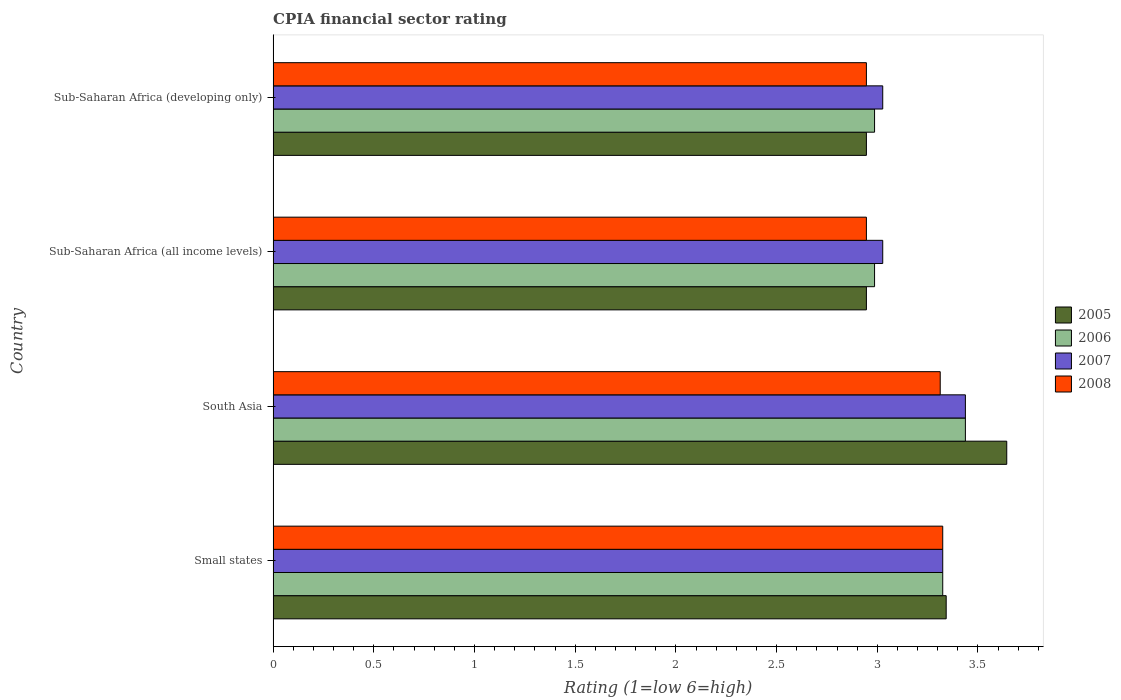How many different coloured bars are there?
Your answer should be compact. 4. How many groups of bars are there?
Give a very brief answer. 4. What is the CPIA rating in 2005 in South Asia?
Ensure brevity in your answer.  3.64. Across all countries, what is the maximum CPIA rating in 2005?
Provide a short and direct response. 3.64. Across all countries, what is the minimum CPIA rating in 2008?
Your answer should be compact. 2.95. In which country was the CPIA rating in 2006 minimum?
Provide a succinct answer. Sub-Saharan Africa (all income levels). What is the total CPIA rating in 2007 in the graph?
Your response must be concise. 12.82. What is the difference between the CPIA rating in 2007 in Small states and that in South Asia?
Your answer should be compact. -0.11. What is the difference between the CPIA rating in 2008 in South Asia and the CPIA rating in 2007 in Sub-Saharan Africa (all income levels)?
Give a very brief answer. 0.29. What is the average CPIA rating in 2008 per country?
Provide a short and direct response. 3.13. What is the difference between the CPIA rating in 2005 and CPIA rating in 2006 in South Asia?
Your response must be concise. 0.21. What is the ratio of the CPIA rating in 2007 in Sub-Saharan Africa (all income levels) to that in Sub-Saharan Africa (developing only)?
Offer a terse response. 1. What is the difference between the highest and the second highest CPIA rating in 2008?
Keep it short and to the point. 0.01. What is the difference between the highest and the lowest CPIA rating in 2005?
Provide a succinct answer. 0.7. In how many countries, is the CPIA rating in 2008 greater than the average CPIA rating in 2008 taken over all countries?
Offer a very short reply. 2. Is it the case that in every country, the sum of the CPIA rating in 2006 and CPIA rating in 2007 is greater than the sum of CPIA rating in 2008 and CPIA rating in 2005?
Your answer should be very brief. No. What does the 3rd bar from the bottom in South Asia represents?
Your answer should be very brief. 2007. How many bars are there?
Your answer should be compact. 16. How are the legend labels stacked?
Your answer should be very brief. Vertical. What is the title of the graph?
Offer a very short reply. CPIA financial sector rating. What is the label or title of the Y-axis?
Give a very brief answer. Country. What is the Rating (1=low 6=high) of 2005 in Small states?
Your response must be concise. 3.34. What is the Rating (1=low 6=high) of 2006 in Small states?
Your answer should be compact. 3.33. What is the Rating (1=low 6=high) of 2007 in Small states?
Keep it short and to the point. 3.33. What is the Rating (1=low 6=high) in 2008 in Small states?
Give a very brief answer. 3.33. What is the Rating (1=low 6=high) of 2005 in South Asia?
Give a very brief answer. 3.64. What is the Rating (1=low 6=high) of 2006 in South Asia?
Keep it short and to the point. 3.44. What is the Rating (1=low 6=high) in 2007 in South Asia?
Make the answer very short. 3.44. What is the Rating (1=low 6=high) of 2008 in South Asia?
Offer a very short reply. 3.31. What is the Rating (1=low 6=high) in 2005 in Sub-Saharan Africa (all income levels)?
Provide a succinct answer. 2.95. What is the Rating (1=low 6=high) of 2006 in Sub-Saharan Africa (all income levels)?
Give a very brief answer. 2.99. What is the Rating (1=low 6=high) of 2007 in Sub-Saharan Africa (all income levels)?
Offer a terse response. 3.03. What is the Rating (1=low 6=high) of 2008 in Sub-Saharan Africa (all income levels)?
Provide a succinct answer. 2.95. What is the Rating (1=low 6=high) in 2005 in Sub-Saharan Africa (developing only)?
Make the answer very short. 2.95. What is the Rating (1=low 6=high) in 2006 in Sub-Saharan Africa (developing only)?
Offer a very short reply. 2.99. What is the Rating (1=low 6=high) in 2007 in Sub-Saharan Africa (developing only)?
Keep it short and to the point. 3.03. What is the Rating (1=low 6=high) in 2008 in Sub-Saharan Africa (developing only)?
Your answer should be very brief. 2.95. Across all countries, what is the maximum Rating (1=low 6=high) of 2005?
Give a very brief answer. 3.64. Across all countries, what is the maximum Rating (1=low 6=high) of 2006?
Ensure brevity in your answer.  3.44. Across all countries, what is the maximum Rating (1=low 6=high) in 2007?
Provide a short and direct response. 3.44. Across all countries, what is the maximum Rating (1=low 6=high) of 2008?
Give a very brief answer. 3.33. Across all countries, what is the minimum Rating (1=low 6=high) in 2005?
Give a very brief answer. 2.95. Across all countries, what is the minimum Rating (1=low 6=high) in 2006?
Provide a succinct answer. 2.99. Across all countries, what is the minimum Rating (1=low 6=high) in 2007?
Offer a terse response. 3.03. Across all countries, what is the minimum Rating (1=low 6=high) of 2008?
Your response must be concise. 2.95. What is the total Rating (1=low 6=high) of 2005 in the graph?
Make the answer very short. 12.88. What is the total Rating (1=low 6=high) of 2006 in the graph?
Keep it short and to the point. 12.74. What is the total Rating (1=low 6=high) in 2007 in the graph?
Offer a terse response. 12.82. What is the total Rating (1=low 6=high) of 2008 in the graph?
Provide a succinct answer. 12.53. What is the difference between the Rating (1=low 6=high) in 2005 in Small states and that in South Asia?
Make the answer very short. -0.3. What is the difference between the Rating (1=low 6=high) in 2006 in Small states and that in South Asia?
Your answer should be very brief. -0.11. What is the difference between the Rating (1=low 6=high) in 2007 in Small states and that in South Asia?
Offer a terse response. -0.11. What is the difference between the Rating (1=low 6=high) in 2008 in Small states and that in South Asia?
Your answer should be very brief. 0.01. What is the difference between the Rating (1=low 6=high) of 2005 in Small states and that in Sub-Saharan Africa (all income levels)?
Your response must be concise. 0.4. What is the difference between the Rating (1=low 6=high) of 2006 in Small states and that in Sub-Saharan Africa (all income levels)?
Offer a terse response. 0.34. What is the difference between the Rating (1=low 6=high) of 2007 in Small states and that in Sub-Saharan Africa (all income levels)?
Your answer should be very brief. 0.3. What is the difference between the Rating (1=low 6=high) of 2008 in Small states and that in Sub-Saharan Africa (all income levels)?
Your response must be concise. 0.38. What is the difference between the Rating (1=low 6=high) of 2005 in Small states and that in Sub-Saharan Africa (developing only)?
Offer a very short reply. 0.4. What is the difference between the Rating (1=low 6=high) in 2006 in Small states and that in Sub-Saharan Africa (developing only)?
Your answer should be very brief. 0.34. What is the difference between the Rating (1=low 6=high) of 2007 in Small states and that in Sub-Saharan Africa (developing only)?
Keep it short and to the point. 0.3. What is the difference between the Rating (1=low 6=high) in 2008 in Small states and that in Sub-Saharan Africa (developing only)?
Your response must be concise. 0.38. What is the difference between the Rating (1=low 6=high) of 2005 in South Asia and that in Sub-Saharan Africa (all income levels)?
Offer a very short reply. 0.7. What is the difference between the Rating (1=low 6=high) of 2006 in South Asia and that in Sub-Saharan Africa (all income levels)?
Your answer should be very brief. 0.45. What is the difference between the Rating (1=low 6=high) in 2007 in South Asia and that in Sub-Saharan Africa (all income levels)?
Provide a succinct answer. 0.41. What is the difference between the Rating (1=low 6=high) in 2008 in South Asia and that in Sub-Saharan Africa (all income levels)?
Your answer should be compact. 0.37. What is the difference between the Rating (1=low 6=high) in 2005 in South Asia and that in Sub-Saharan Africa (developing only)?
Your answer should be very brief. 0.7. What is the difference between the Rating (1=low 6=high) in 2006 in South Asia and that in Sub-Saharan Africa (developing only)?
Your answer should be compact. 0.45. What is the difference between the Rating (1=low 6=high) in 2007 in South Asia and that in Sub-Saharan Africa (developing only)?
Ensure brevity in your answer.  0.41. What is the difference between the Rating (1=low 6=high) in 2008 in South Asia and that in Sub-Saharan Africa (developing only)?
Give a very brief answer. 0.37. What is the difference between the Rating (1=low 6=high) in 2005 in Sub-Saharan Africa (all income levels) and that in Sub-Saharan Africa (developing only)?
Your response must be concise. 0. What is the difference between the Rating (1=low 6=high) of 2007 in Sub-Saharan Africa (all income levels) and that in Sub-Saharan Africa (developing only)?
Give a very brief answer. 0. What is the difference between the Rating (1=low 6=high) in 2005 in Small states and the Rating (1=low 6=high) in 2006 in South Asia?
Ensure brevity in your answer.  -0.1. What is the difference between the Rating (1=low 6=high) of 2005 in Small states and the Rating (1=low 6=high) of 2007 in South Asia?
Keep it short and to the point. -0.1. What is the difference between the Rating (1=low 6=high) of 2005 in Small states and the Rating (1=low 6=high) of 2008 in South Asia?
Keep it short and to the point. 0.03. What is the difference between the Rating (1=low 6=high) of 2006 in Small states and the Rating (1=low 6=high) of 2007 in South Asia?
Your response must be concise. -0.11. What is the difference between the Rating (1=low 6=high) in 2006 in Small states and the Rating (1=low 6=high) in 2008 in South Asia?
Make the answer very short. 0.01. What is the difference between the Rating (1=low 6=high) in 2007 in Small states and the Rating (1=low 6=high) in 2008 in South Asia?
Keep it short and to the point. 0.01. What is the difference between the Rating (1=low 6=high) in 2005 in Small states and the Rating (1=low 6=high) in 2006 in Sub-Saharan Africa (all income levels)?
Offer a terse response. 0.36. What is the difference between the Rating (1=low 6=high) of 2005 in Small states and the Rating (1=low 6=high) of 2007 in Sub-Saharan Africa (all income levels)?
Give a very brief answer. 0.32. What is the difference between the Rating (1=low 6=high) of 2005 in Small states and the Rating (1=low 6=high) of 2008 in Sub-Saharan Africa (all income levels)?
Make the answer very short. 0.4. What is the difference between the Rating (1=low 6=high) in 2006 in Small states and the Rating (1=low 6=high) in 2007 in Sub-Saharan Africa (all income levels)?
Provide a succinct answer. 0.3. What is the difference between the Rating (1=low 6=high) in 2006 in Small states and the Rating (1=low 6=high) in 2008 in Sub-Saharan Africa (all income levels)?
Give a very brief answer. 0.38. What is the difference between the Rating (1=low 6=high) in 2007 in Small states and the Rating (1=low 6=high) in 2008 in Sub-Saharan Africa (all income levels)?
Offer a very short reply. 0.38. What is the difference between the Rating (1=low 6=high) of 2005 in Small states and the Rating (1=low 6=high) of 2006 in Sub-Saharan Africa (developing only)?
Your answer should be compact. 0.36. What is the difference between the Rating (1=low 6=high) in 2005 in Small states and the Rating (1=low 6=high) in 2007 in Sub-Saharan Africa (developing only)?
Offer a very short reply. 0.32. What is the difference between the Rating (1=low 6=high) in 2005 in Small states and the Rating (1=low 6=high) in 2008 in Sub-Saharan Africa (developing only)?
Make the answer very short. 0.4. What is the difference between the Rating (1=low 6=high) of 2006 in Small states and the Rating (1=low 6=high) of 2007 in Sub-Saharan Africa (developing only)?
Make the answer very short. 0.3. What is the difference between the Rating (1=low 6=high) of 2006 in Small states and the Rating (1=low 6=high) of 2008 in Sub-Saharan Africa (developing only)?
Offer a terse response. 0.38. What is the difference between the Rating (1=low 6=high) of 2007 in Small states and the Rating (1=low 6=high) of 2008 in Sub-Saharan Africa (developing only)?
Your answer should be very brief. 0.38. What is the difference between the Rating (1=low 6=high) in 2005 in South Asia and the Rating (1=low 6=high) in 2006 in Sub-Saharan Africa (all income levels)?
Ensure brevity in your answer.  0.66. What is the difference between the Rating (1=low 6=high) of 2005 in South Asia and the Rating (1=low 6=high) of 2007 in Sub-Saharan Africa (all income levels)?
Make the answer very short. 0.62. What is the difference between the Rating (1=low 6=high) in 2005 in South Asia and the Rating (1=low 6=high) in 2008 in Sub-Saharan Africa (all income levels)?
Give a very brief answer. 0.7. What is the difference between the Rating (1=low 6=high) of 2006 in South Asia and the Rating (1=low 6=high) of 2007 in Sub-Saharan Africa (all income levels)?
Give a very brief answer. 0.41. What is the difference between the Rating (1=low 6=high) in 2006 in South Asia and the Rating (1=low 6=high) in 2008 in Sub-Saharan Africa (all income levels)?
Offer a terse response. 0.49. What is the difference between the Rating (1=low 6=high) of 2007 in South Asia and the Rating (1=low 6=high) of 2008 in Sub-Saharan Africa (all income levels)?
Your answer should be very brief. 0.49. What is the difference between the Rating (1=low 6=high) of 2005 in South Asia and the Rating (1=low 6=high) of 2006 in Sub-Saharan Africa (developing only)?
Offer a very short reply. 0.66. What is the difference between the Rating (1=low 6=high) of 2005 in South Asia and the Rating (1=low 6=high) of 2007 in Sub-Saharan Africa (developing only)?
Make the answer very short. 0.62. What is the difference between the Rating (1=low 6=high) in 2005 in South Asia and the Rating (1=low 6=high) in 2008 in Sub-Saharan Africa (developing only)?
Keep it short and to the point. 0.7. What is the difference between the Rating (1=low 6=high) in 2006 in South Asia and the Rating (1=low 6=high) in 2007 in Sub-Saharan Africa (developing only)?
Ensure brevity in your answer.  0.41. What is the difference between the Rating (1=low 6=high) in 2006 in South Asia and the Rating (1=low 6=high) in 2008 in Sub-Saharan Africa (developing only)?
Offer a terse response. 0.49. What is the difference between the Rating (1=low 6=high) of 2007 in South Asia and the Rating (1=low 6=high) of 2008 in Sub-Saharan Africa (developing only)?
Keep it short and to the point. 0.49. What is the difference between the Rating (1=low 6=high) in 2005 in Sub-Saharan Africa (all income levels) and the Rating (1=low 6=high) in 2006 in Sub-Saharan Africa (developing only)?
Make the answer very short. -0.04. What is the difference between the Rating (1=low 6=high) in 2005 in Sub-Saharan Africa (all income levels) and the Rating (1=low 6=high) in 2007 in Sub-Saharan Africa (developing only)?
Offer a terse response. -0.08. What is the difference between the Rating (1=low 6=high) in 2005 in Sub-Saharan Africa (all income levels) and the Rating (1=low 6=high) in 2008 in Sub-Saharan Africa (developing only)?
Your response must be concise. 0. What is the difference between the Rating (1=low 6=high) in 2006 in Sub-Saharan Africa (all income levels) and the Rating (1=low 6=high) in 2007 in Sub-Saharan Africa (developing only)?
Make the answer very short. -0.04. What is the difference between the Rating (1=low 6=high) in 2006 in Sub-Saharan Africa (all income levels) and the Rating (1=low 6=high) in 2008 in Sub-Saharan Africa (developing only)?
Provide a succinct answer. 0.04. What is the difference between the Rating (1=low 6=high) of 2007 in Sub-Saharan Africa (all income levels) and the Rating (1=low 6=high) of 2008 in Sub-Saharan Africa (developing only)?
Offer a terse response. 0.08. What is the average Rating (1=low 6=high) of 2005 per country?
Provide a short and direct response. 3.22. What is the average Rating (1=low 6=high) of 2006 per country?
Provide a succinct answer. 3.18. What is the average Rating (1=low 6=high) in 2007 per country?
Make the answer very short. 3.2. What is the average Rating (1=low 6=high) in 2008 per country?
Offer a very short reply. 3.13. What is the difference between the Rating (1=low 6=high) of 2005 and Rating (1=low 6=high) of 2006 in Small states?
Offer a very short reply. 0.02. What is the difference between the Rating (1=low 6=high) of 2005 and Rating (1=low 6=high) of 2007 in Small states?
Give a very brief answer. 0.02. What is the difference between the Rating (1=low 6=high) in 2005 and Rating (1=low 6=high) in 2008 in Small states?
Your answer should be very brief. 0.02. What is the difference between the Rating (1=low 6=high) in 2006 and Rating (1=low 6=high) in 2007 in Small states?
Give a very brief answer. 0. What is the difference between the Rating (1=low 6=high) in 2007 and Rating (1=low 6=high) in 2008 in Small states?
Your answer should be very brief. 0. What is the difference between the Rating (1=low 6=high) of 2005 and Rating (1=low 6=high) of 2006 in South Asia?
Ensure brevity in your answer.  0.21. What is the difference between the Rating (1=low 6=high) in 2005 and Rating (1=low 6=high) in 2007 in South Asia?
Your response must be concise. 0.21. What is the difference between the Rating (1=low 6=high) of 2005 and Rating (1=low 6=high) of 2008 in South Asia?
Provide a succinct answer. 0.33. What is the difference between the Rating (1=low 6=high) of 2006 and Rating (1=low 6=high) of 2007 in South Asia?
Give a very brief answer. 0. What is the difference between the Rating (1=low 6=high) of 2007 and Rating (1=low 6=high) of 2008 in South Asia?
Provide a short and direct response. 0.12. What is the difference between the Rating (1=low 6=high) in 2005 and Rating (1=low 6=high) in 2006 in Sub-Saharan Africa (all income levels)?
Offer a terse response. -0.04. What is the difference between the Rating (1=low 6=high) in 2005 and Rating (1=low 6=high) in 2007 in Sub-Saharan Africa (all income levels)?
Keep it short and to the point. -0.08. What is the difference between the Rating (1=low 6=high) in 2005 and Rating (1=low 6=high) in 2008 in Sub-Saharan Africa (all income levels)?
Your response must be concise. 0. What is the difference between the Rating (1=low 6=high) in 2006 and Rating (1=low 6=high) in 2007 in Sub-Saharan Africa (all income levels)?
Give a very brief answer. -0.04. What is the difference between the Rating (1=low 6=high) of 2006 and Rating (1=low 6=high) of 2008 in Sub-Saharan Africa (all income levels)?
Offer a very short reply. 0.04. What is the difference between the Rating (1=low 6=high) in 2007 and Rating (1=low 6=high) in 2008 in Sub-Saharan Africa (all income levels)?
Make the answer very short. 0.08. What is the difference between the Rating (1=low 6=high) of 2005 and Rating (1=low 6=high) of 2006 in Sub-Saharan Africa (developing only)?
Offer a very short reply. -0.04. What is the difference between the Rating (1=low 6=high) in 2005 and Rating (1=low 6=high) in 2007 in Sub-Saharan Africa (developing only)?
Give a very brief answer. -0.08. What is the difference between the Rating (1=low 6=high) of 2005 and Rating (1=low 6=high) of 2008 in Sub-Saharan Africa (developing only)?
Provide a succinct answer. 0. What is the difference between the Rating (1=low 6=high) in 2006 and Rating (1=low 6=high) in 2007 in Sub-Saharan Africa (developing only)?
Provide a short and direct response. -0.04. What is the difference between the Rating (1=low 6=high) in 2006 and Rating (1=low 6=high) in 2008 in Sub-Saharan Africa (developing only)?
Make the answer very short. 0.04. What is the difference between the Rating (1=low 6=high) of 2007 and Rating (1=low 6=high) of 2008 in Sub-Saharan Africa (developing only)?
Give a very brief answer. 0.08. What is the ratio of the Rating (1=low 6=high) of 2005 in Small states to that in South Asia?
Provide a short and direct response. 0.92. What is the ratio of the Rating (1=low 6=high) in 2006 in Small states to that in South Asia?
Your answer should be compact. 0.97. What is the ratio of the Rating (1=low 6=high) in 2007 in Small states to that in South Asia?
Make the answer very short. 0.97. What is the ratio of the Rating (1=low 6=high) in 2008 in Small states to that in South Asia?
Provide a succinct answer. 1. What is the ratio of the Rating (1=low 6=high) of 2005 in Small states to that in Sub-Saharan Africa (all income levels)?
Your response must be concise. 1.13. What is the ratio of the Rating (1=low 6=high) in 2006 in Small states to that in Sub-Saharan Africa (all income levels)?
Offer a very short reply. 1.11. What is the ratio of the Rating (1=low 6=high) in 2007 in Small states to that in Sub-Saharan Africa (all income levels)?
Your response must be concise. 1.1. What is the ratio of the Rating (1=low 6=high) of 2008 in Small states to that in Sub-Saharan Africa (all income levels)?
Offer a very short reply. 1.13. What is the ratio of the Rating (1=low 6=high) of 2005 in Small states to that in Sub-Saharan Africa (developing only)?
Your answer should be very brief. 1.13. What is the ratio of the Rating (1=low 6=high) in 2006 in Small states to that in Sub-Saharan Africa (developing only)?
Provide a succinct answer. 1.11. What is the ratio of the Rating (1=low 6=high) of 2007 in Small states to that in Sub-Saharan Africa (developing only)?
Your answer should be very brief. 1.1. What is the ratio of the Rating (1=low 6=high) of 2008 in Small states to that in Sub-Saharan Africa (developing only)?
Provide a short and direct response. 1.13. What is the ratio of the Rating (1=low 6=high) of 2005 in South Asia to that in Sub-Saharan Africa (all income levels)?
Offer a terse response. 1.24. What is the ratio of the Rating (1=low 6=high) of 2006 in South Asia to that in Sub-Saharan Africa (all income levels)?
Provide a succinct answer. 1.15. What is the ratio of the Rating (1=low 6=high) of 2007 in South Asia to that in Sub-Saharan Africa (all income levels)?
Your response must be concise. 1.14. What is the ratio of the Rating (1=low 6=high) of 2008 in South Asia to that in Sub-Saharan Africa (all income levels)?
Offer a very short reply. 1.12. What is the ratio of the Rating (1=low 6=high) of 2005 in South Asia to that in Sub-Saharan Africa (developing only)?
Make the answer very short. 1.24. What is the ratio of the Rating (1=low 6=high) in 2006 in South Asia to that in Sub-Saharan Africa (developing only)?
Keep it short and to the point. 1.15. What is the ratio of the Rating (1=low 6=high) of 2007 in South Asia to that in Sub-Saharan Africa (developing only)?
Keep it short and to the point. 1.14. What is the ratio of the Rating (1=low 6=high) of 2008 in South Asia to that in Sub-Saharan Africa (developing only)?
Provide a succinct answer. 1.12. What is the ratio of the Rating (1=low 6=high) of 2008 in Sub-Saharan Africa (all income levels) to that in Sub-Saharan Africa (developing only)?
Ensure brevity in your answer.  1. What is the difference between the highest and the second highest Rating (1=low 6=high) in 2005?
Provide a short and direct response. 0.3. What is the difference between the highest and the second highest Rating (1=low 6=high) in 2006?
Provide a succinct answer. 0.11. What is the difference between the highest and the second highest Rating (1=low 6=high) in 2007?
Give a very brief answer. 0.11. What is the difference between the highest and the second highest Rating (1=low 6=high) of 2008?
Your answer should be very brief. 0.01. What is the difference between the highest and the lowest Rating (1=low 6=high) in 2005?
Make the answer very short. 0.7. What is the difference between the highest and the lowest Rating (1=low 6=high) in 2006?
Ensure brevity in your answer.  0.45. What is the difference between the highest and the lowest Rating (1=low 6=high) in 2007?
Offer a terse response. 0.41. What is the difference between the highest and the lowest Rating (1=low 6=high) of 2008?
Offer a very short reply. 0.38. 